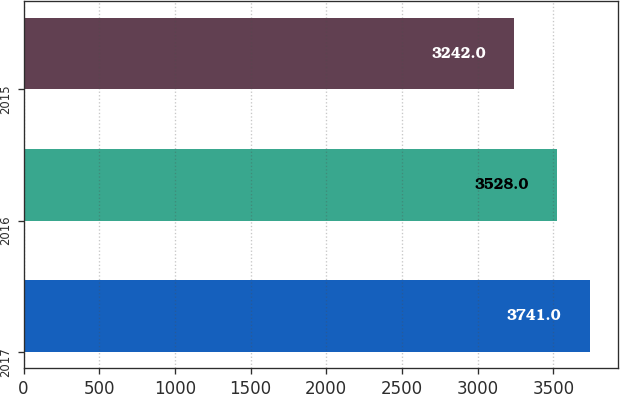Convert chart. <chart><loc_0><loc_0><loc_500><loc_500><bar_chart><fcel>2017<fcel>2016<fcel>2015<nl><fcel>3741<fcel>3528<fcel>3242<nl></chart> 